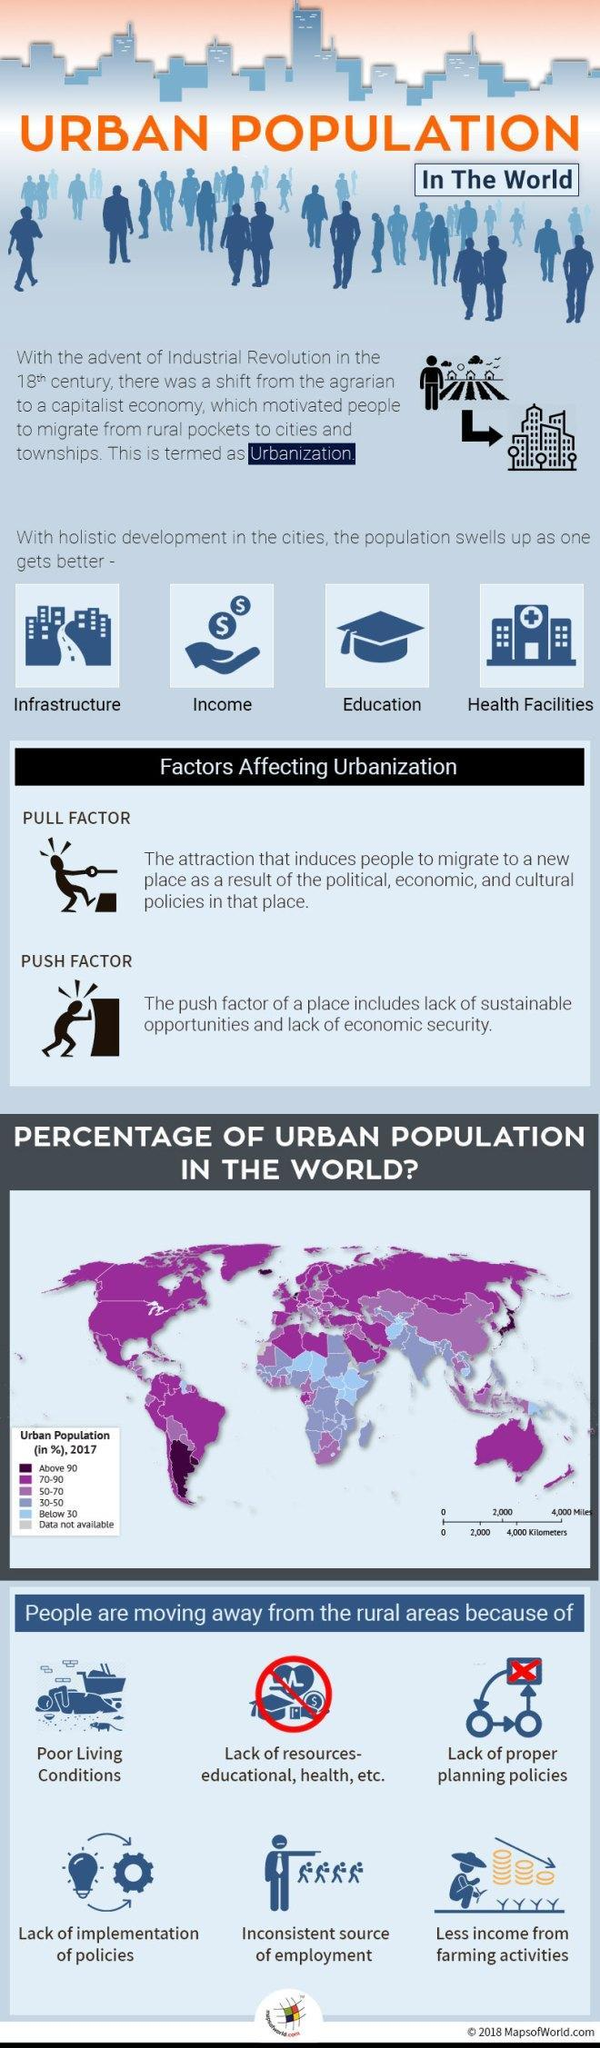What percentage of the population is urban in the northern-most part of the map?
Answer the question with a short phrase. 70-90 Which are the different types of factors affecting Urbanization? Pull Factor, Push Factor What percentage of the population is urban in the south-east island? 70-90 What is the third reason for people moving to urban places? Lack of proper planning policies How many attractions of cities are listed other than "Infrastructure" and "Income"? 2 How many different factors affects Urbanization? 2 What is the fourth attraction of cities as listed in the infographic? Health Facilities What is the sixth reason for people moving to urban places? Less income from farming activities What is the fifth reason for people moving to urban places? Inconsistent source of employment What are the main features of the "Pull Factor" in Urbanization? political, economic, and cultural policies in that place 